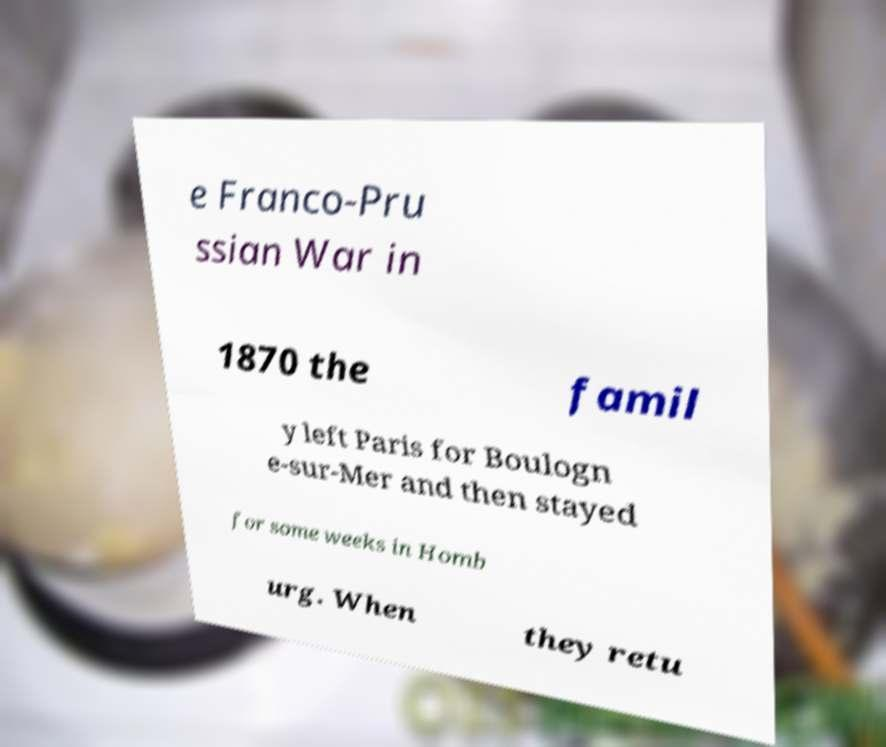Can you accurately transcribe the text from the provided image for me? e Franco-Pru ssian War in 1870 the famil y left Paris for Boulogn e-sur-Mer and then stayed for some weeks in Homb urg. When they retu 